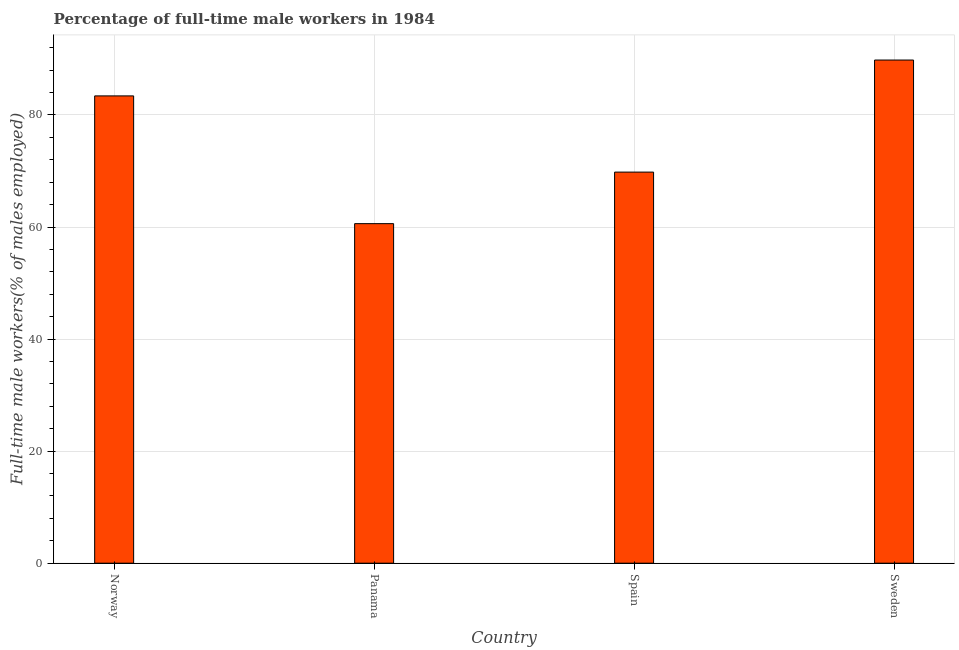Does the graph contain grids?
Offer a terse response. Yes. What is the title of the graph?
Provide a succinct answer. Percentage of full-time male workers in 1984. What is the label or title of the X-axis?
Ensure brevity in your answer.  Country. What is the label or title of the Y-axis?
Keep it short and to the point. Full-time male workers(% of males employed). What is the percentage of full-time male workers in Panama?
Your answer should be very brief. 60.6. Across all countries, what is the maximum percentage of full-time male workers?
Give a very brief answer. 89.8. Across all countries, what is the minimum percentage of full-time male workers?
Ensure brevity in your answer.  60.6. In which country was the percentage of full-time male workers maximum?
Ensure brevity in your answer.  Sweden. In which country was the percentage of full-time male workers minimum?
Ensure brevity in your answer.  Panama. What is the sum of the percentage of full-time male workers?
Provide a succinct answer. 303.6. What is the difference between the percentage of full-time male workers in Norway and Spain?
Provide a short and direct response. 13.6. What is the average percentage of full-time male workers per country?
Offer a terse response. 75.9. What is the median percentage of full-time male workers?
Offer a terse response. 76.6. In how many countries, is the percentage of full-time male workers greater than 40 %?
Keep it short and to the point. 4. What is the ratio of the percentage of full-time male workers in Spain to that in Sweden?
Provide a succinct answer. 0.78. Is the difference between the percentage of full-time male workers in Panama and Spain greater than the difference between any two countries?
Provide a succinct answer. No. What is the difference between the highest and the second highest percentage of full-time male workers?
Make the answer very short. 6.4. What is the difference between the highest and the lowest percentage of full-time male workers?
Your answer should be very brief. 29.2. How many countries are there in the graph?
Offer a very short reply. 4. What is the difference between two consecutive major ticks on the Y-axis?
Offer a very short reply. 20. Are the values on the major ticks of Y-axis written in scientific E-notation?
Provide a succinct answer. No. What is the Full-time male workers(% of males employed) of Norway?
Offer a very short reply. 83.4. What is the Full-time male workers(% of males employed) in Panama?
Provide a succinct answer. 60.6. What is the Full-time male workers(% of males employed) in Spain?
Offer a very short reply. 69.8. What is the Full-time male workers(% of males employed) in Sweden?
Ensure brevity in your answer.  89.8. What is the difference between the Full-time male workers(% of males employed) in Norway and Panama?
Make the answer very short. 22.8. What is the difference between the Full-time male workers(% of males employed) in Panama and Sweden?
Your answer should be compact. -29.2. What is the ratio of the Full-time male workers(% of males employed) in Norway to that in Panama?
Offer a very short reply. 1.38. What is the ratio of the Full-time male workers(% of males employed) in Norway to that in Spain?
Your response must be concise. 1.2. What is the ratio of the Full-time male workers(% of males employed) in Norway to that in Sweden?
Give a very brief answer. 0.93. What is the ratio of the Full-time male workers(% of males employed) in Panama to that in Spain?
Ensure brevity in your answer.  0.87. What is the ratio of the Full-time male workers(% of males employed) in Panama to that in Sweden?
Your response must be concise. 0.68. What is the ratio of the Full-time male workers(% of males employed) in Spain to that in Sweden?
Provide a short and direct response. 0.78. 